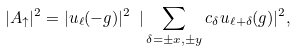<formula> <loc_0><loc_0><loc_500><loc_500>| A _ { \uparrow } | ^ { 2 } = | u _ { \ell } ( - g ) | ^ { 2 } \ | \sum _ { \delta = \pm x , \pm y } c _ { \delta } u _ { \ell + \delta } ( g ) | ^ { 2 } ,</formula> 